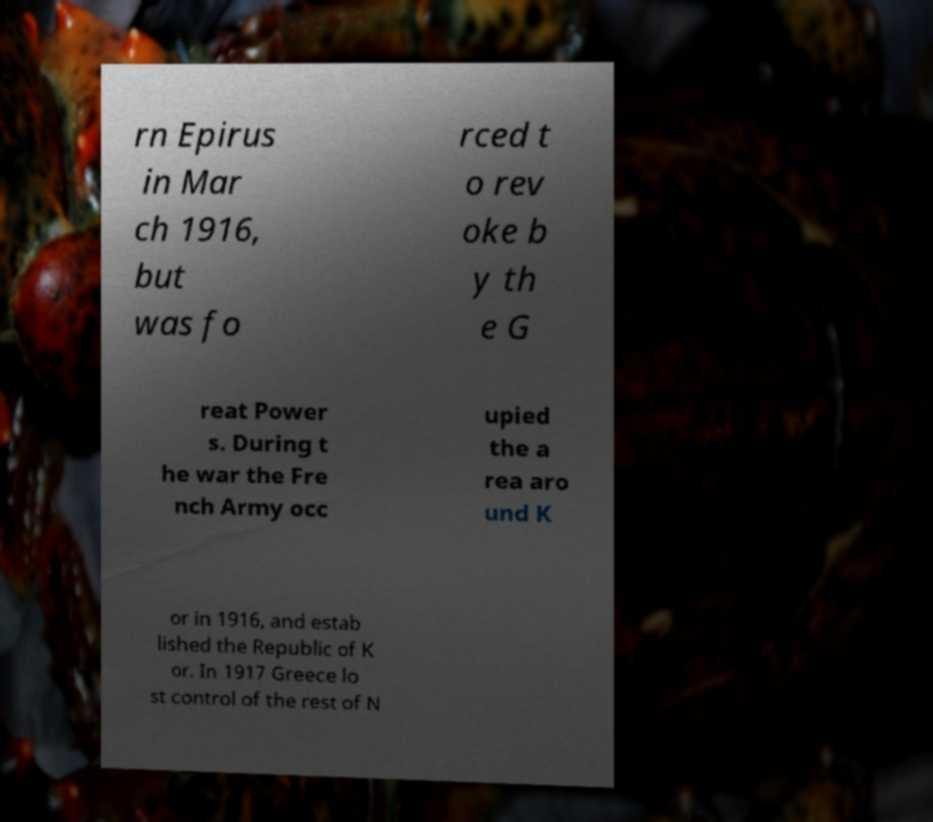For documentation purposes, I need the text within this image transcribed. Could you provide that? rn Epirus in Mar ch 1916, but was fo rced t o rev oke b y th e G reat Power s. During t he war the Fre nch Army occ upied the a rea aro und K or in 1916, and estab lished the Republic of K or. In 1917 Greece lo st control of the rest of N 